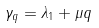<formula> <loc_0><loc_0><loc_500><loc_500>\gamma _ { q } = \lambda _ { 1 } + \mu q</formula> 